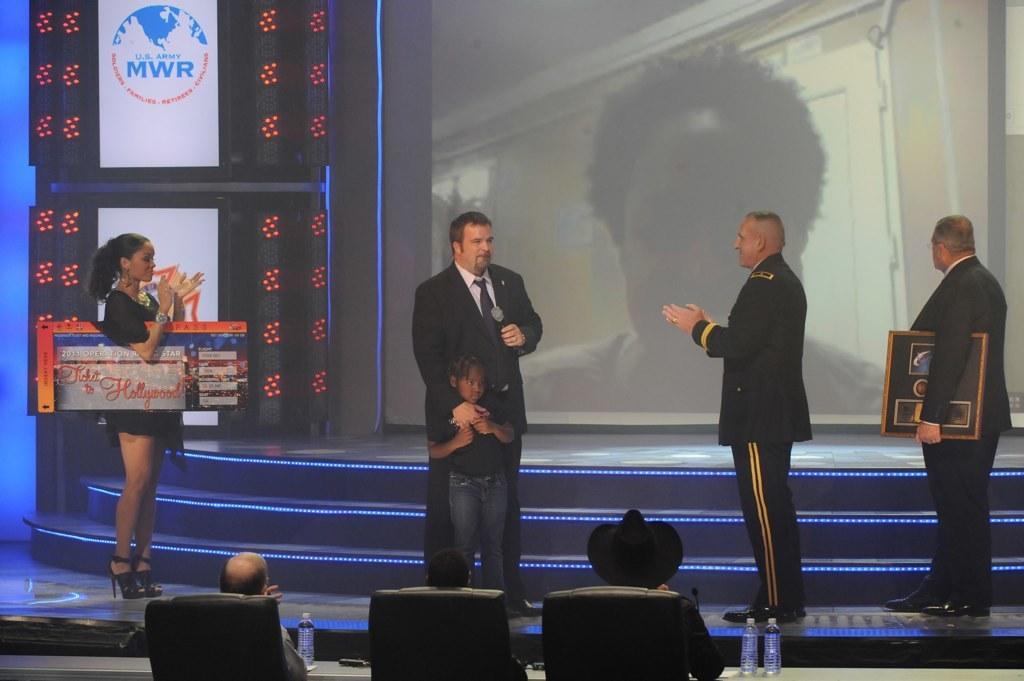How would you summarize this image in a sentence or two? In the picture we can see few people standing on the stage and clapping the hands and one man is holding a microphone and he is in a black color blazer and tie and holding a child standing near him and in front of them we can see some people are sitting in the chairs and in the background we can see some steps with lights and behind it we can see a screen and person face image on it and besides we can see some board with lights near it. 